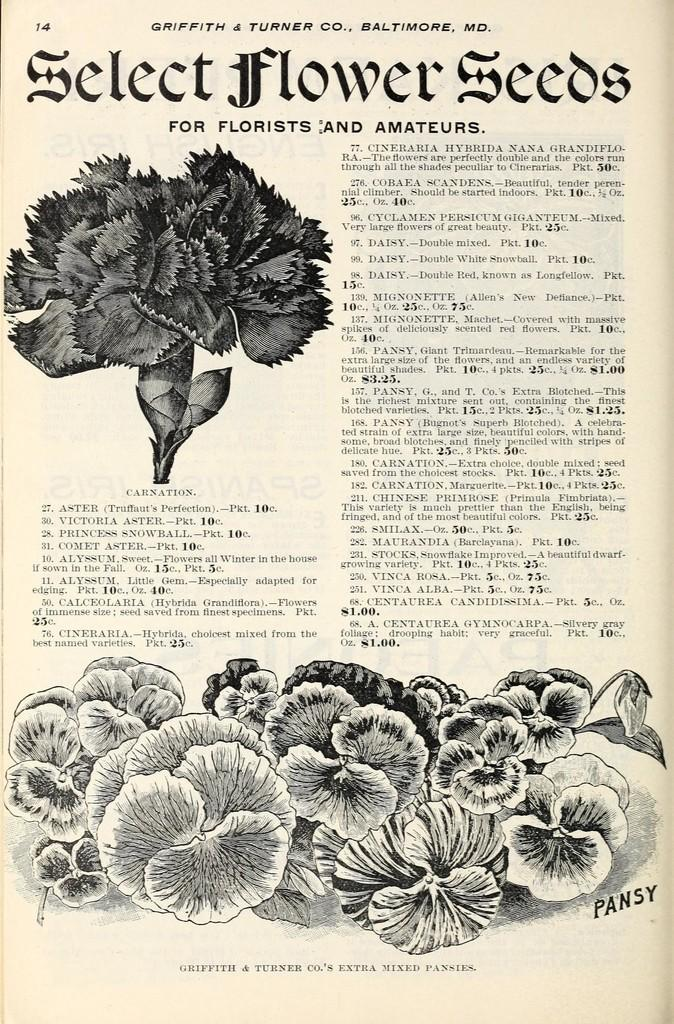What is present on the paper in the image? There is text, numbers, and flowers on the paper in the image. Can you describe the text on the paper? Unfortunately, the specific content of the text cannot be determined from the image. What color is the background of the image? The background of the image is white in color. What type of music can be heard playing in the background of the image? There is no music present in the image, as it is a still image of a paper with text, numbers, and flowers. 